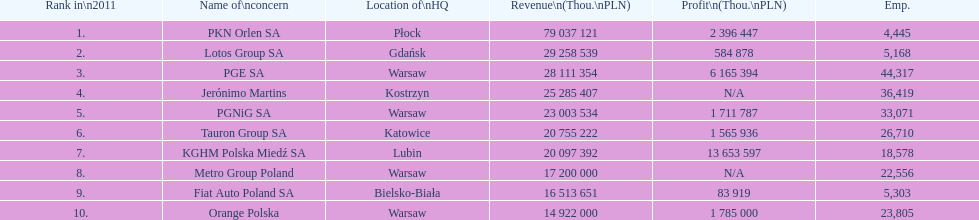Which company had the most revenue? PKN Orlen SA. 